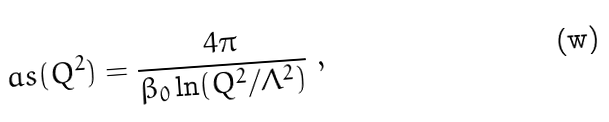<formula> <loc_0><loc_0><loc_500><loc_500>\ a s ( Q ^ { 2 } ) = \frac { 4 \pi } { \beta _ { 0 } \ln ( Q ^ { 2 } / \Lambda ^ { 2 } ) } \ ,</formula> 